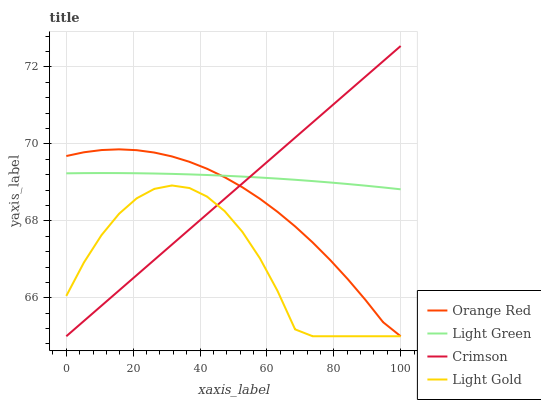Does Light Gold have the minimum area under the curve?
Answer yes or no. Yes. Does Light Green have the maximum area under the curve?
Answer yes or no. Yes. Does Orange Red have the minimum area under the curve?
Answer yes or no. No. Does Orange Red have the maximum area under the curve?
Answer yes or no. No. Is Crimson the smoothest?
Answer yes or no. Yes. Is Light Gold the roughest?
Answer yes or no. Yes. Is Orange Red the smoothest?
Answer yes or no. No. Is Orange Red the roughest?
Answer yes or no. No. Does Crimson have the lowest value?
Answer yes or no. Yes. Does Light Green have the lowest value?
Answer yes or no. No. Does Crimson have the highest value?
Answer yes or no. Yes. Does Orange Red have the highest value?
Answer yes or no. No. Is Light Gold less than Light Green?
Answer yes or no. Yes. Is Light Green greater than Light Gold?
Answer yes or no. Yes. Does Light Gold intersect Orange Red?
Answer yes or no. Yes. Is Light Gold less than Orange Red?
Answer yes or no. No. Is Light Gold greater than Orange Red?
Answer yes or no. No. Does Light Gold intersect Light Green?
Answer yes or no. No. 